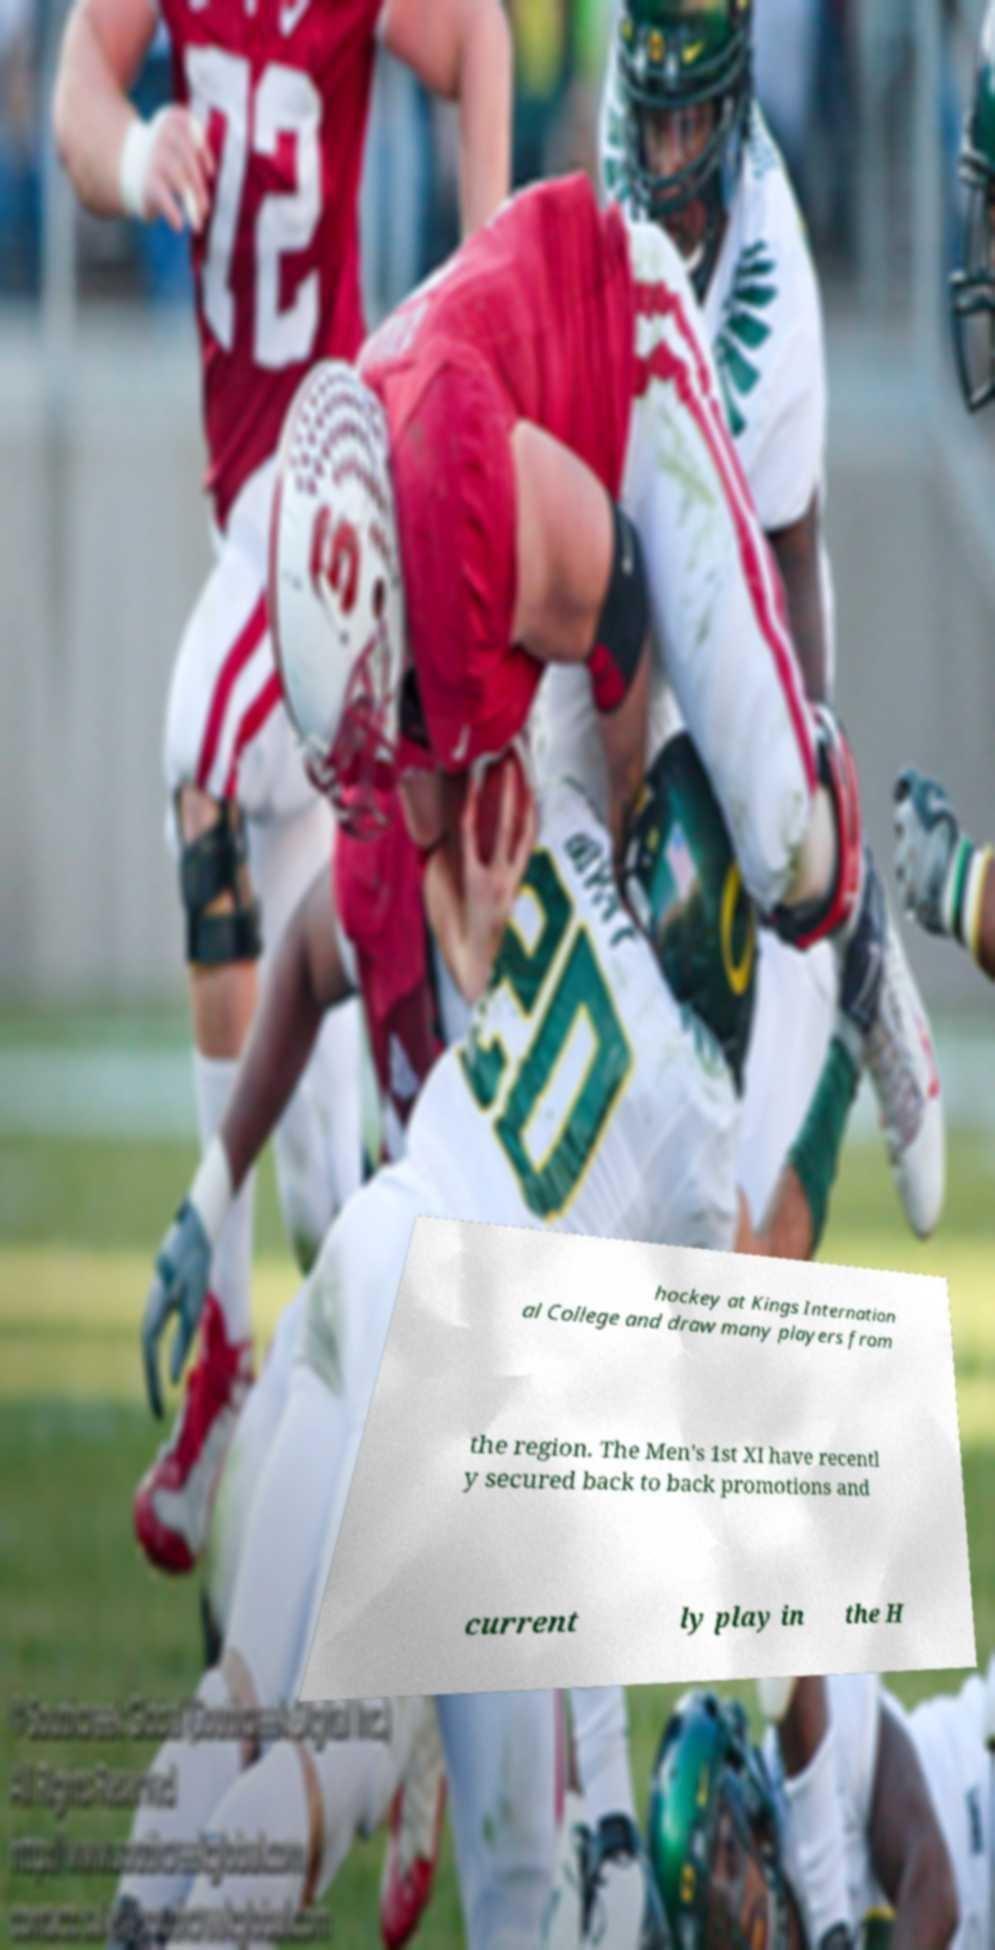Could you assist in decoding the text presented in this image and type it out clearly? hockey at Kings Internation al College and draw many players from the region. The Men's 1st XI have recentl y secured back to back promotions and current ly play in the H 